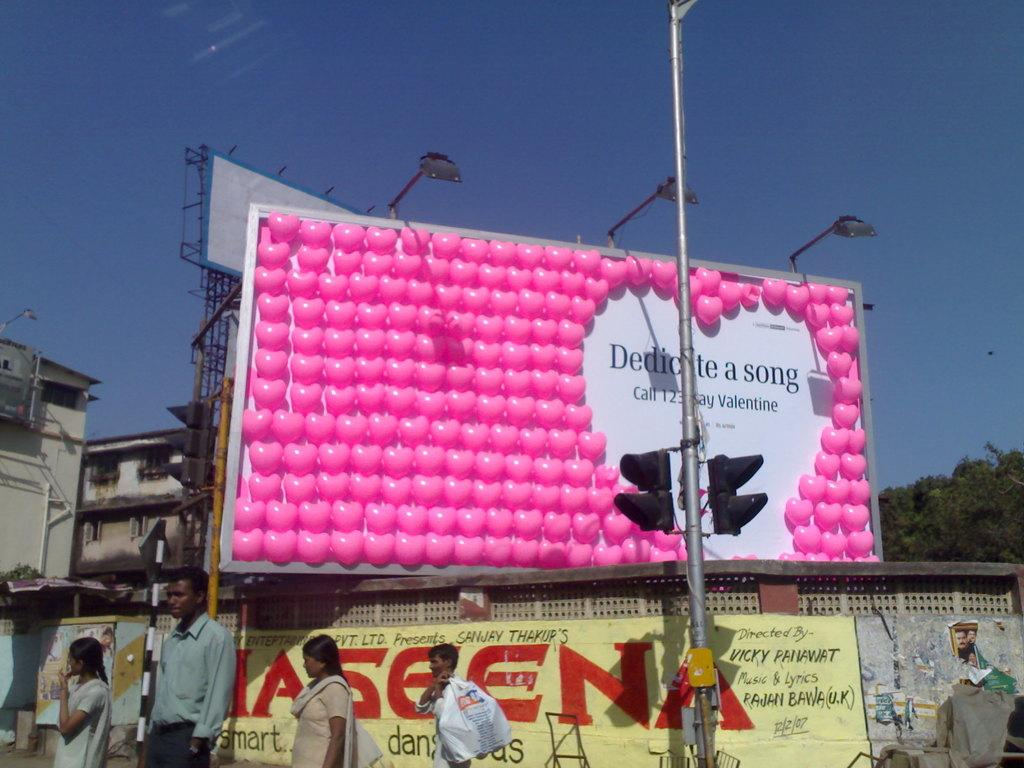<image>
Present a compact description of the photo's key features. A billboard covered in pink balloons says we should dedicate a song. 